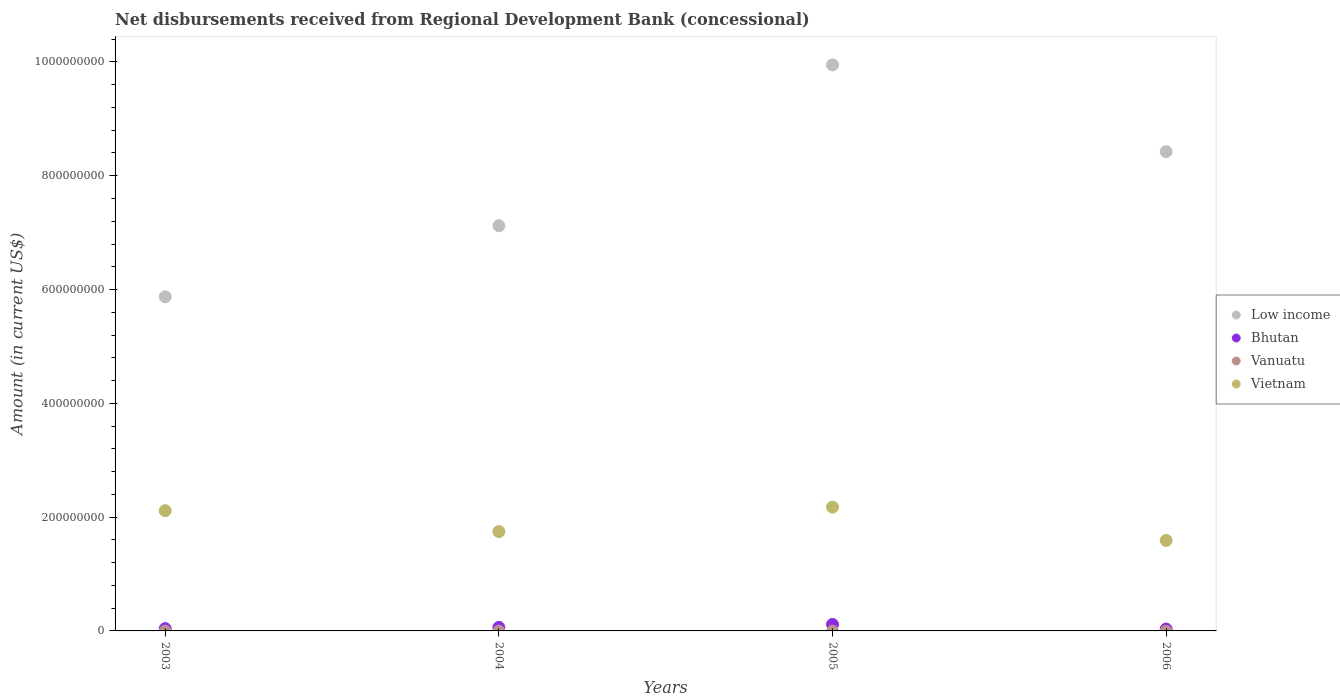Is the number of dotlines equal to the number of legend labels?
Your answer should be compact. No. What is the amount of disbursements received from Regional Development Bank in Low income in 2004?
Offer a terse response. 7.12e+08. Across all years, what is the maximum amount of disbursements received from Regional Development Bank in Vietnam?
Make the answer very short. 2.18e+08. Across all years, what is the minimum amount of disbursements received from Regional Development Bank in Low income?
Ensure brevity in your answer.  5.87e+08. What is the difference between the amount of disbursements received from Regional Development Bank in Vietnam in 2004 and that in 2006?
Ensure brevity in your answer.  1.56e+07. What is the difference between the amount of disbursements received from Regional Development Bank in Bhutan in 2003 and the amount of disbursements received from Regional Development Bank in Low income in 2005?
Offer a very short reply. -9.91e+08. What is the average amount of disbursements received from Regional Development Bank in Vietnam per year?
Make the answer very short. 1.91e+08. In the year 2006, what is the difference between the amount of disbursements received from Regional Development Bank in Low income and amount of disbursements received from Regional Development Bank in Bhutan?
Give a very brief answer. 8.39e+08. In how many years, is the amount of disbursements received from Regional Development Bank in Low income greater than 880000000 US$?
Give a very brief answer. 1. What is the ratio of the amount of disbursements received from Regional Development Bank in Bhutan in 2004 to that in 2006?
Your answer should be compact. 1.86. What is the difference between the highest and the second highest amount of disbursements received from Regional Development Bank in Low income?
Your answer should be compact. 1.52e+08. What is the difference between the highest and the lowest amount of disbursements received from Regional Development Bank in Bhutan?
Provide a short and direct response. 8.09e+06. In how many years, is the amount of disbursements received from Regional Development Bank in Vanuatu greater than the average amount of disbursements received from Regional Development Bank in Vanuatu taken over all years?
Keep it short and to the point. 0. Does the amount of disbursements received from Regional Development Bank in Bhutan monotonically increase over the years?
Provide a short and direct response. No. Is the amount of disbursements received from Regional Development Bank in Bhutan strictly greater than the amount of disbursements received from Regional Development Bank in Vietnam over the years?
Offer a terse response. No. Is the amount of disbursements received from Regional Development Bank in Bhutan strictly less than the amount of disbursements received from Regional Development Bank in Vietnam over the years?
Your answer should be very brief. Yes. How many dotlines are there?
Your answer should be very brief. 3. What is the difference between two consecutive major ticks on the Y-axis?
Your answer should be very brief. 2.00e+08. Does the graph contain grids?
Give a very brief answer. No. How many legend labels are there?
Offer a very short reply. 4. What is the title of the graph?
Your response must be concise. Net disbursements received from Regional Development Bank (concessional). What is the Amount (in current US$) of Low income in 2003?
Provide a short and direct response. 5.87e+08. What is the Amount (in current US$) of Bhutan in 2003?
Provide a succinct answer. 4.04e+06. What is the Amount (in current US$) in Vanuatu in 2003?
Ensure brevity in your answer.  0. What is the Amount (in current US$) of Vietnam in 2003?
Offer a terse response. 2.11e+08. What is the Amount (in current US$) of Low income in 2004?
Offer a very short reply. 7.12e+08. What is the Amount (in current US$) of Bhutan in 2004?
Your answer should be compact. 6.13e+06. What is the Amount (in current US$) of Vanuatu in 2004?
Provide a succinct answer. 0. What is the Amount (in current US$) in Vietnam in 2004?
Your answer should be compact. 1.75e+08. What is the Amount (in current US$) of Low income in 2005?
Provide a succinct answer. 9.95e+08. What is the Amount (in current US$) in Bhutan in 2005?
Make the answer very short. 1.14e+07. What is the Amount (in current US$) of Vanuatu in 2005?
Your response must be concise. 0. What is the Amount (in current US$) in Vietnam in 2005?
Offer a terse response. 2.18e+08. What is the Amount (in current US$) in Low income in 2006?
Your response must be concise. 8.42e+08. What is the Amount (in current US$) in Bhutan in 2006?
Your answer should be compact. 3.30e+06. What is the Amount (in current US$) in Vanuatu in 2006?
Your answer should be very brief. 0. What is the Amount (in current US$) of Vietnam in 2006?
Make the answer very short. 1.59e+08. Across all years, what is the maximum Amount (in current US$) of Low income?
Make the answer very short. 9.95e+08. Across all years, what is the maximum Amount (in current US$) in Bhutan?
Make the answer very short. 1.14e+07. Across all years, what is the maximum Amount (in current US$) in Vietnam?
Offer a terse response. 2.18e+08. Across all years, what is the minimum Amount (in current US$) of Low income?
Give a very brief answer. 5.87e+08. Across all years, what is the minimum Amount (in current US$) of Bhutan?
Your answer should be very brief. 3.30e+06. Across all years, what is the minimum Amount (in current US$) of Vietnam?
Ensure brevity in your answer.  1.59e+08. What is the total Amount (in current US$) of Low income in the graph?
Ensure brevity in your answer.  3.14e+09. What is the total Amount (in current US$) in Bhutan in the graph?
Your response must be concise. 2.49e+07. What is the total Amount (in current US$) in Vietnam in the graph?
Give a very brief answer. 7.63e+08. What is the difference between the Amount (in current US$) of Low income in 2003 and that in 2004?
Your answer should be very brief. -1.25e+08. What is the difference between the Amount (in current US$) of Bhutan in 2003 and that in 2004?
Your answer should be very brief. -2.09e+06. What is the difference between the Amount (in current US$) of Vietnam in 2003 and that in 2004?
Your response must be concise. 3.67e+07. What is the difference between the Amount (in current US$) of Low income in 2003 and that in 2005?
Your response must be concise. -4.08e+08. What is the difference between the Amount (in current US$) of Bhutan in 2003 and that in 2005?
Your response must be concise. -7.35e+06. What is the difference between the Amount (in current US$) of Vietnam in 2003 and that in 2005?
Your answer should be very brief. -6.31e+06. What is the difference between the Amount (in current US$) in Low income in 2003 and that in 2006?
Ensure brevity in your answer.  -2.55e+08. What is the difference between the Amount (in current US$) of Bhutan in 2003 and that in 2006?
Your answer should be very brief. 7.36e+05. What is the difference between the Amount (in current US$) in Vietnam in 2003 and that in 2006?
Make the answer very short. 5.23e+07. What is the difference between the Amount (in current US$) of Low income in 2004 and that in 2005?
Provide a short and direct response. -2.83e+08. What is the difference between the Amount (in current US$) of Bhutan in 2004 and that in 2005?
Your response must be concise. -5.26e+06. What is the difference between the Amount (in current US$) of Vietnam in 2004 and that in 2005?
Provide a short and direct response. -4.30e+07. What is the difference between the Amount (in current US$) of Low income in 2004 and that in 2006?
Provide a succinct answer. -1.30e+08. What is the difference between the Amount (in current US$) in Bhutan in 2004 and that in 2006?
Make the answer very short. 2.83e+06. What is the difference between the Amount (in current US$) of Vietnam in 2004 and that in 2006?
Provide a succinct answer. 1.56e+07. What is the difference between the Amount (in current US$) in Low income in 2005 and that in 2006?
Provide a short and direct response. 1.52e+08. What is the difference between the Amount (in current US$) of Bhutan in 2005 and that in 2006?
Keep it short and to the point. 8.09e+06. What is the difference between the Amount (in current US$) of Vietnam in 2005 and that in 2006?
Your response must be concise. 5.86e+07. What is the difference between the Amount (in current US$) of Low income in 2003 and the Amount (in current US$) of Bhutan in 2004?
Your answer should be very brief. 5.81e+08. What is the difference between the Amount (in current US$) in Low income in 2003 and the Amount (in current US$) in Vietnam in 2004?
Make the answer very short. 4.13e+08. What is the difference between the Amount (in current US$) of Bhutan in 2003 and the Amount (in current US$) of Vietnam in 2004?
Make the answer very short. -1.71e+08. What is the difference between the Amount (in current US$) of Low income in 2003 and the Amount (in current US$) of Bhutan in 2005?
Make the answer very short. 5.76e+08. What is the difference between the Amount (in current US$) of Low income in 2003 and the Amount (in current US$) of Vietnam in 2005?
Your answer should be very brief. 3.70e+08. What is the difference between the Amount (in current US$) in Bhutan in 2003 and the Amount (in current US$) in Vietnam in 2005?
Keep it short and to the point. -2.14e+08. What is the difference between the Amount (in current US$) in Low income in 2003 and the Amount (in current US$) in Bhutan in 2006?
Your response must be concise. 5.84e+08. What is the difference between the Amount (in current US$) of Low income in 2003 and the Amount (in current US$) of Vietnam in 2006?
Make the answer very short. 4.28e+08. What is the difference between the Amount (in current US$) of Bhutan in 2003 and the Amount (in current US$) of Vietnam in 2006?
Provide a short and direct response. -1.55e+08. What is the difference between the Amount (in current US$) in Low income in 2004 and the Amount (in current US$) in Bhutan in 2005?
Offer a very short reply. 7.01e+08. What is the difference between the Amount (in current US$) in Low income in 2004 and the Amount (in current US$) in Vietnam in 2005?
Offer a terse response. 4.95e+08. What is the difference between the Amount (in current US$) in Bhutan in 2004 and the Amount (in current US$) in Vietnam in 2005?
Offer a very short reply. -2.11e+08. What is the difference between the Amount (in current US$) of Low income in 2004 and the Amount (in current US$) of Bhutan in 2006?
Make the answer very short. 7.09e+08. What is the difference between the Amount (in current US$) in Low income in 2004 and the Amount (in current US$) in Vietnam in 2006?
Ensure brevity in your answer.  5.53e+08. What is the difference between the Amount (in current US$) of Bhutan in 2004 and the Amount (in current US$) of Vietnam in 2006?
Keep it short and to the point. -1.53e+08. What is the difference between the Amount (in current US$) of Low income in 2005 and the Amount (in current US$) of Bhutan in 2006?
Provide a short and direct response. 9.92e+08. What is the difference between the Amount (in current US$) of Low income in 2005 and the Amount (in current US$) of Vietnam in 2006?
Keep it short and to the point. 8.36e+08. What is the difference between the Amount (in current US$) of Bhutan in 2005 and the Amount (in current US$) of Vietnam in 2006?
Ensure brevity in your answer.  -1.48e+08. What is the average Amount (in current US$) in Low income per year?
Your response must be concise. 7.84e+08. What is the average Amount (in current US$) of Bhutan per year?
Provide a succinct answer. 6.22e+06. What is the average Amount (in current US$) in Vietnam per year?
Ensure brevity in your answer.  1.91e+08. In the year 2003, what is the difference between the Amount (in current US$) in Low income and Amount (in current US$) in Bhutan?
Ensure brevity in your answer.  5.83e+08. In the year 2003, what is the difference between the Amount (in current US$) in Low income and Amount (in current US$) in Vietnam?
Make the answer very short. 3.76e+08. In the year 2003, what is the difference between the Amount (in current US$) in Bhutan and Amount (in current US$) in Vietnam?
Your response must be concise. -2.07e+08. In the year 2004, what is the difference between the Amount (in current US$) of Low income and Amount (in current US$) of Bhutan?
Offer a terse response. 7.06e+08. In the year 2004, what is the difference between the Amount (in current US$) of Low income and Amount (in current US$) of Vietnam?
Offer a terse response. 5.38e+08. In the year 2004, what is the difference between the Amount (in current US$) of Bhutan and Amount (in current US$) of Vietnam?
Your answer should be very brief. -1.69e+08. In the year 2005, what is the difference between the Amount (in current US$) in Low income and Amount (in current US$) in Bhutan?
Your answer should be compact. 9.83e+08. In the year 2005, what is the difference between the Amount (in current US$) of Low income and Amount (in current US$) of Vietnam?
Your answer should be compact. 7.77e+08. In the year 2005, what is the difference between the Amount (in current US$) of Bhutan and Amount (in current US$) of Vietnam?
Provide a short and direct response. -2.06e+08. In the year 2006, what is the difference between the Amount (in current US$) of Low income and Amount (in current US$) of Bhutan?
Your response must be concise. 8.39e+08. In the year 2006, what is the difference between the Amount (in current US$) of Low income and Amount (in current US$) of Vietnam?
Your response must be concise. 6.83e+08. In the year 2006, what is the difference between the Amount (in current US$) of Bhutan and Amount (in current US$) of Vietnam?
Keep it short and to the point. -1.56e+08. What is the ratio of the Amount (in current US$) in Low income in 2003 to that in 2004?
Keep it short and to the point. 0.82. What is the ratio of the Amount (in current US$) of Bhutan in 2003 to that in 2004?
Provide a short and direct response. 0.66. What is the ratio of the Amount (in current US$) of Vietnam in 2003 to that in 2004?
Offer a terse response. 1.21. What is the ratio of the Amount (in current US$) of Low income in 2003 to that in 2005?
Your answer should be very brief. 0.59. What is the ratio of the Amount (in current US$) of Bhutan in 2003 to that in 2005?
Your answer should be very brief. 0.35. What is the ratio of the Amount (in current US$) of Vietnam in 2003 to that in 2005?
Offer a very short reply. 0.97. What is the ratio of the Amount (in current US$) in Low income in 2003 to that in 2006?
Your answer should be compact. 0.7. What is the ratio of the Amount (in current US$) of Bhutan in 2003 to that in 2006?
Offer a very short reply. 1.22. What is the ratio of the Amount (in current US$) in Vietnam in 2003 to that in 2006?
Ensure brevity in your answer.  1.33. What is the ratio of the Amount (in current US$) in Low income in 2004 to that in 2005?
Provide a succinct answer. 0.72. What is the ratio of the Amount (in current US$) of Bhutan in 2004 to that in 2005?
Your answer should be compact. 0.54. What is the ratio of the Amount (in current US$) of Vietnam in 2004 to that in 2005?
Keep it short and to the point. 0.8. What is the ratio of the Amount (in current US$) in Low income in 2004 to that in 2006?
Your answer should be compact. 0.85. What is the ratio of the Amount (in current US$) in Bhutan in 2004 to that in 2006?
Your answer should be compact. 1.86. What is the ratio of the Amount (in current US$) in Vietnam in 2004 to that in 2006?
Offer a very short reply. 1.1. What is the ratio of the Amount (in current US$) of Low income in 2005 to that in 2006?
Keep it short and to the point. 1.18. What is the ratio of the Amount (in current US$) in Bhutan in 2005 to that in 2006?
Offer a very short reply. 3.45. What is the ratio of the Amount (in current US$) in Vietnam in 2005 to that in 2006?
Provide a succinct answer. 1.37. What is the difference between the highest and the second highest Amount (in current US$) of Low income?
Ensure brevity in your answer.  1.52e+08. What is the difference between the highest and the second highest Amount (in current US$) in Bhutan?
Keep it short and to the point. 5.26e+06. What is the difference between the highest and the second highest Amount (in current US$) in Vietnam?
Offer a very short reply. 6.31e+06. What is the difference between the highest and the lowest Amount (in current US$) in Low income?
Give a very brief answer. 4.08e+08. What is the difference between the highest and the lowest Amount (in current US$) in Bhutan?
Make the answer very short. 8.09e+06. What is the difference between the highest and the lowest Amount (in current US$) of Vietnam?
Give a very brief answer. 5.86e+07. 